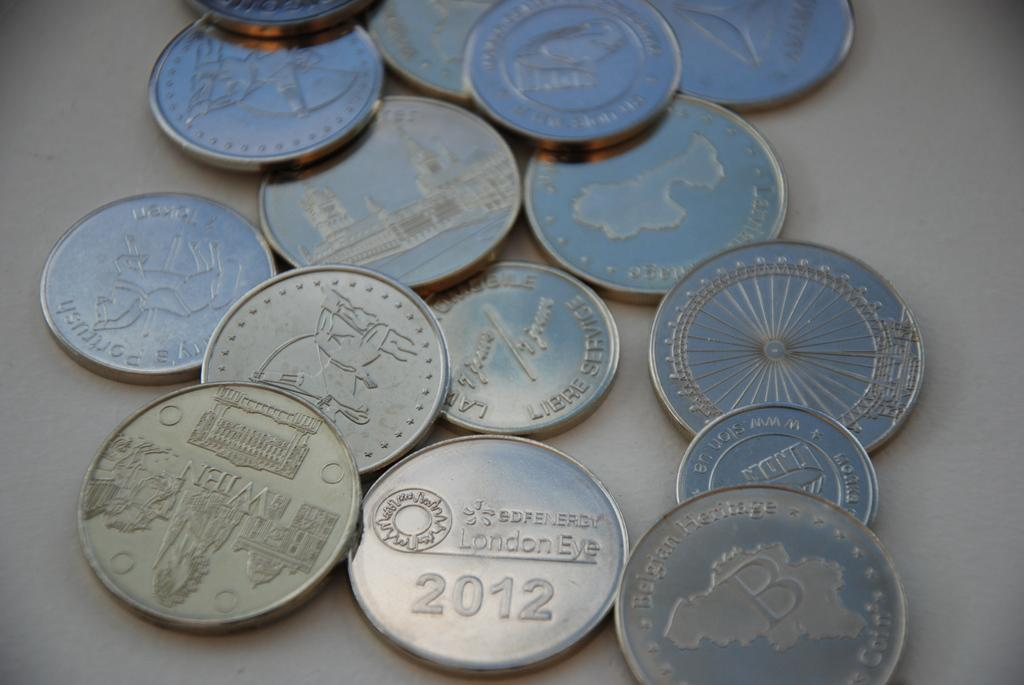<image>
Provide a brief description of the given image. Various coin currencies scattered on a table with one of the coins saying London Eye 2012. 